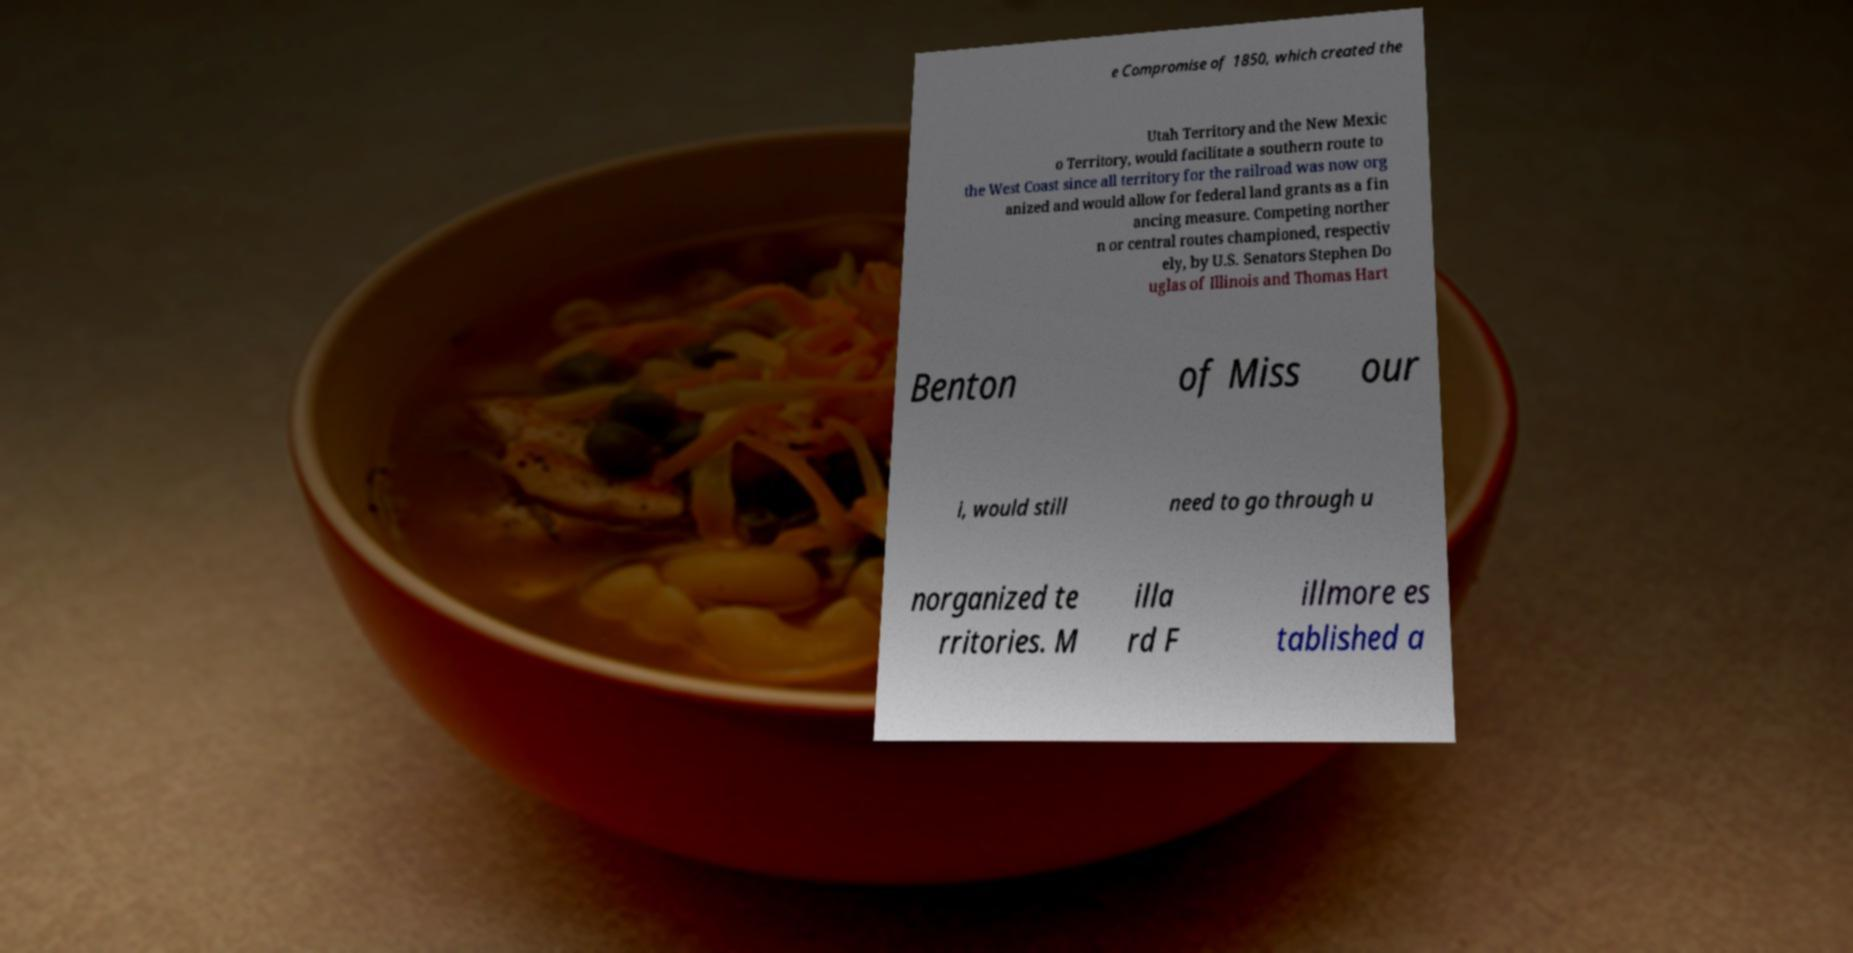What messages or text are displayed in this image? I need them in a readable, typed format. e Compromise of 1850, which created the Utah Territory and the New Mexic o Territory, would facilitate a southern route to the West Coast since all territory for the railroad was now org anized and would allow for federal land grants as a fin ancing measure. Competing norther n or central routes championed, respectiv ely, by U.S. Senators Stephen Do uglas of Illinois and Thomas Hart Benton of Miss our i, would still need to go through u norganized te rritories. M illa rd F illmore es tablished a 